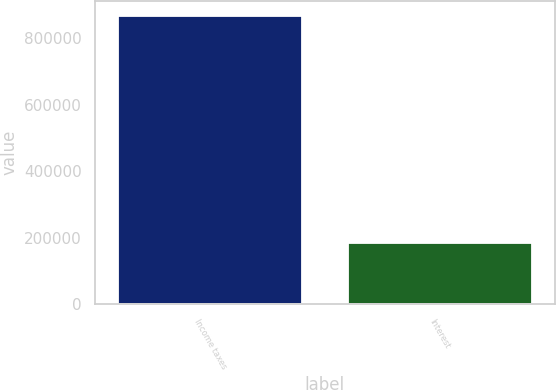Convert chart to OTSL. <chart><loc_0><loc_0><loc_500><loc_500><bar_chart><fcel>Income taxes<fcel>Interest<nl><fcel>868492<fcel>183117<nl></chart> 